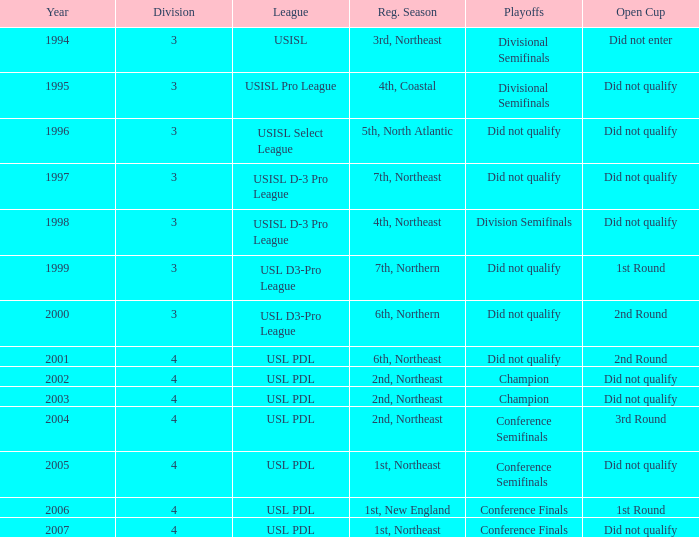Specify the overall count of years for usisl pro league. 1.0. 